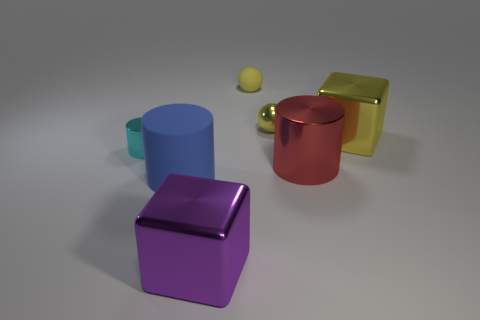What is the size of the ball that is the same color as the tiny matte thing?
Ensure brevity in your answer.  Small. There is a red metallic object that is the same shape as the cyan metallic object; what is its size?
Your answer should be very brief. Large. Is there any other thing that is the same size as the yellow matte thing?
Keep it short and to the point. Yes. There is a yellow metal cube; is it the same size as the metal cube to the left of the red metal cylinder?
Your answer should be very brief. Yes. The rubber thing that is on the right side of the big blue thing has what shape?
Make the answer very short. Sphere. There is a metal block on the right side of the metal object behind the large yellow shiny block; what color is it?
Offer a terse response. Yellow. The other large metallic thing that is the same shape as the cyan thing is what color?
Give a very brief answer. Red. How many large objects have the same color as the tiny matte ball?
Offer a very short reply. 1. There is a large matte thing; is its color the same as the tiny ball that is right of the small yellow rubber thing?
Your answer should be compact. No. There is a shiny object that is both to the left of the yellow metallic sphere and behind the red cylinder; what shape is it?
Your answer should be very brief. Cylinder. 